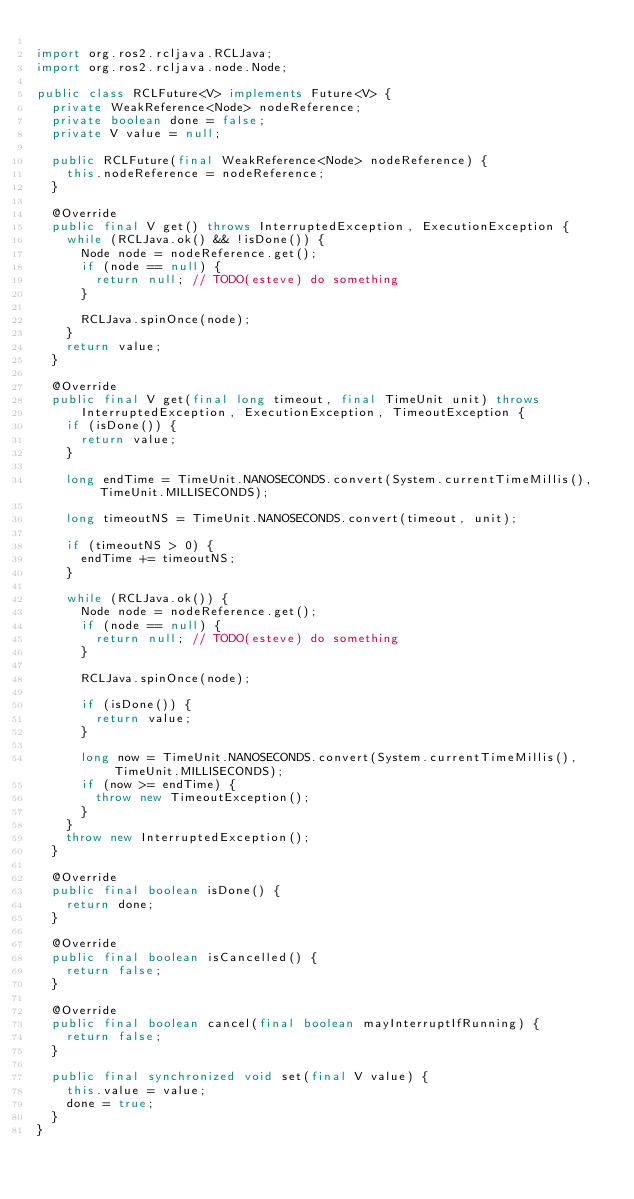Convert code to text. <code><loc_0><loc_0><loc_500><loc_500><_Java_>
import org.ros2.rcljava.RCLJava;
import org.ros2.rcljava.node.Node;

public class RCLFuture<V> implements Future<V> {
  private WeakReference<Node> nodeReference;
  private boolean done = false;
  private V value = null;

  public RCLFuture(final WeakReference<Node> nodeReference) {
    this.nodeReference = nodeReference;
  }

  @Override
  public final V get() throws InterruptedException, ExecutionException {
    while (RCLJava.ok() && !isDone()) {
      Node node = nodeReference.get();
      if (node == null) {
        return null; // TODO(esteve) do something
      }

      RCLJava.spinOnce(node);
    }
    return value;
  }

  @Override
  public final V get(final long timeout, final TimeUnit unit) throws
      InterruptedException, ExecutionException, TimeoutException {
    if (isDone()) {
      return value;
    }

    long endTime = TimeUnit.NANOSECONDS.convert(System.currentTimeMillis(), TimeUnit.MILLISECONDS);

    long timeoutNS = TimeUnit.NANOSECONDS.convert(timeout, unit);

    if (timeoutNS > 0) {
      endTime += timeoutNS;
    }

    while (RCLJava.ok()) {
      Node node = nodeReference.get();
      if (node == null) {
        return null; // TODO(esteve) do something
      }

      RCLJava.spinOnce(node);

      if (isDone()) {
        return value;
      }

      long now = TimeUnit.NANOSECONDS.convert(System.currentTimeMillis(), TimeUnit.MILLISECONDS);
      if (now >= endTime) {
        throw new TimeoutException();
      }
    }
    throw new InterruptedException();
  }

  @Override
  public final boolean isDone() {
    return done;
  }

  @Override
  public final boolean isCancelled() {
    return false;
  }

  @Override
  public final boolean cancel(final boolean mayInterruptIfRunning) {
    return false;
  }

  public final synchronized void set(final V value) {
    this.value = value;
    done = true;
  }
}
</code> 